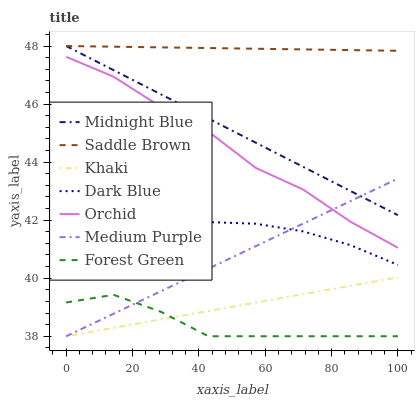Does Forest Green have the minimum area under the curve?
Answer yes or no. Yes. Does Saddle Brown have the maximum area under the curve?
Answer yes or no. Yes. Does Midnight Blue have the minimum area under the curve?
Answer yes or no. No. Does Midnight Blue have the maximum area under the curve?
Answer yes or no. No. Is Saddle Brown the smoothest?
Answer yes or no. Yes. Is Orchid the roughest?
Answer yes or no. Yes. Is Midnight Blue the smoothest?
Answer yes or no. No. Is Midnight Blue the roughest?
Answer yes or no. No. Does Khaki have the lowest value?
Answer yes or no. Yes. Does Midnight Blue have the lowest value?
Answer yes or no. No. Does Saddle Brown have the highest value?
Answer yes or no. Yes. Does Medium Purple have the highest value?
Answer yes or no. No. Is Dark Blue less than Orchid?
Answer yes or no. Yes. Is Dark Blue greater than Forest Green?
Answer yes or no. Yes. Does Dark Blue intersect Medium Purple?
Answer yes or no. Yes. Is Dark Blue less than Medium Purple?
Answer yes or no. No. Is Dark Blue greater than Medium Purple?
Answer yes or no. No. Does Dark Blue intersect Orchid?
Answer yes or no. No. 